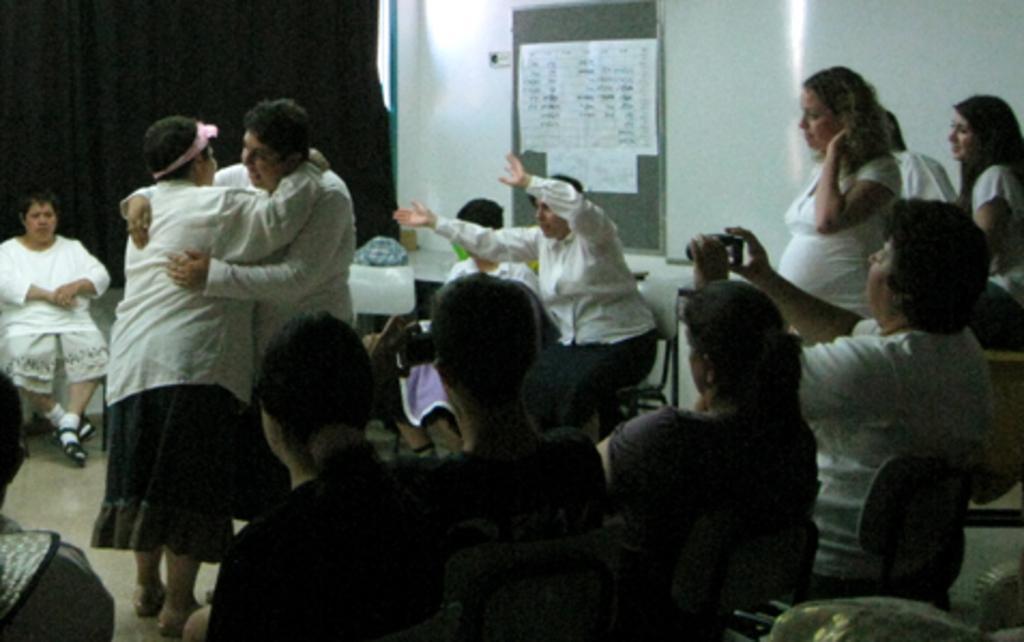How would you summarize this image in a sentence or two? In this picture we can see a group of people sitting on chairs, some people are standing on the floor and two people are holding devices. In the background we can see a board on the wall with papers on it, curtain and some objects. 